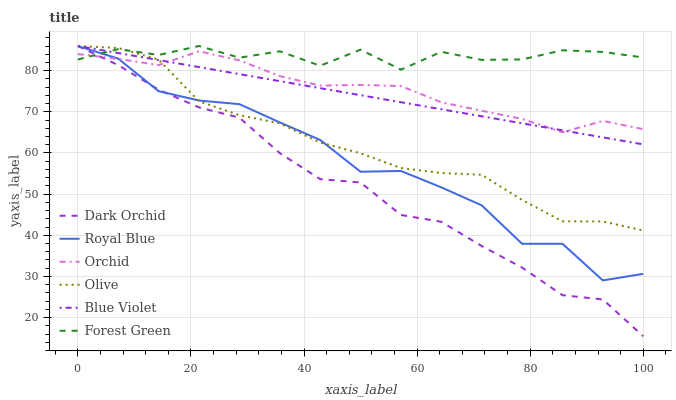Does Dark Orchid have the minimum area under the curve?
Answer yes or no. Yes. Does Forest Green have the maximum area under the curve?
Answer yes or no. Yes. Does Royal Blue have the minimum area under the curve?
Answer yes or no. No. Does Royal Blue have the maximum area under the curve?
Answer yes or no. No. Is Blue Violet the smoothest?
Answer yes or no. Yes. Is Royal Blue the roughest?
Answer yes or no. Yes. Is Forest Green the smoothest?
Answer yes or no. No. Is Forest Green the roughest?
Answer yes or no. No. Does Dark Orchid have the lowest value?
Answer yes or no. Yes. Does Royal Blue have the lowest value?
Answer yes or no. No. Does Blue Violet have the highest value?
Answer yes or no. Yes. Does Orchid have the highest value?
Answer yes or no. No. Does Blue Violet intersect Royal Blue?
Answer yes or no. Yes. Is Blue Violet less than Royal Blue?
Answer yes or no. No. Is Blue Violet greater than Royal Blue?
Answer yes or no. No. 